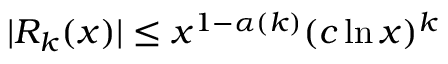<formula> <loc_0><loc_0><loc_500><loc_500>| R _ { k } ( x ) | \leq x ^ { 1 - \alpha ( k ) } ( c \ln x ) ^ { k }</formula> 